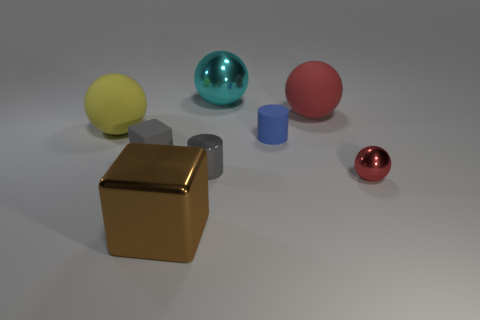Are there any other things that have the same shape as the small blue thing?
Provide a short and direct response. Yes. There is a block that is to the left of the brown metallic cube; is its size the same as the tiny red metal thing?
Offer a very short reply. Yes. What number of metallic objects are tiny red spheres or small gray objects?
Give a very brief answer. 2. There is a metallic sphere that is behind the small red object; what size is it?
Provide a short and direct response. Large. Does the red rubber object have the same shape as the big brown thing?
Provide a short and direct response. No. How many tiny things are either matte things or cyan shiny balls?
Offer a very short reply. 2. There is a rubber block; are there any big rubber objects on the left side of it?
Make the answer very short. Yes. Are there the same number of balls that are right of the tiny sphere and tiny brown blocks?
Your response must be concise. Yes. There is a cyan metal thing that is the same shape as the large red matte thing; what size is it?
Offer a very short reply. Large. Do the gray matte object and the large metallic thing that is in front of the red shiny sphere have the same shape?
Provide a succinct answer. Yes. 